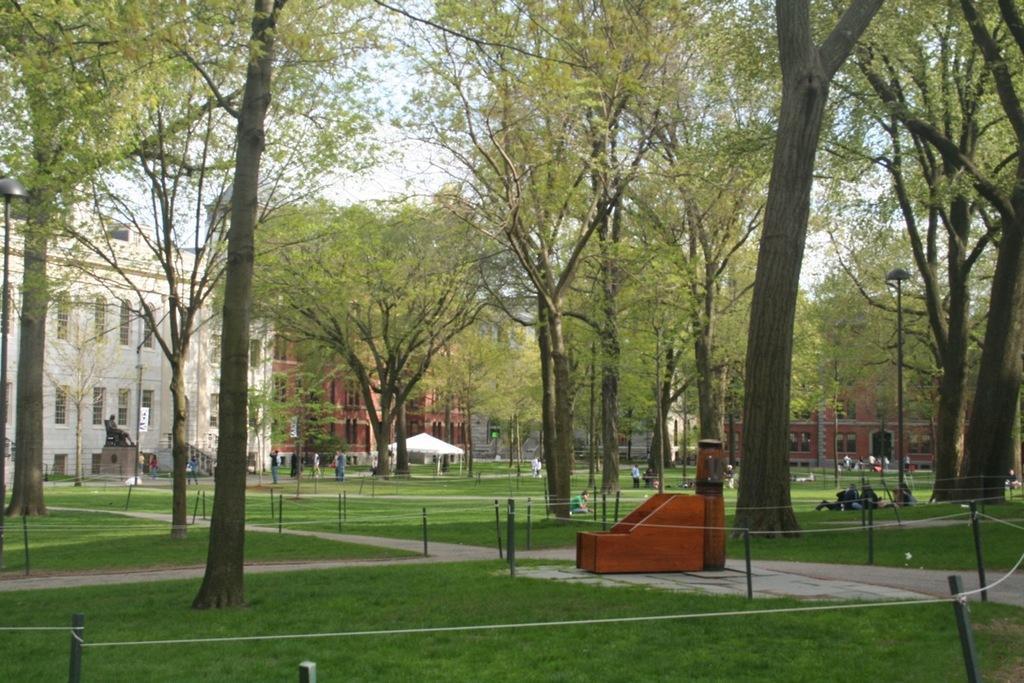Describe this image in one or two sentences. In this image we can see some poles tied with ropes. We can also see some grass, a group of people and an object placed on the ground. On the backside we can see a group of trees, the bark of a tree, tent, a statue, some poles, buildings with windows and the sky which looks cloudy. 